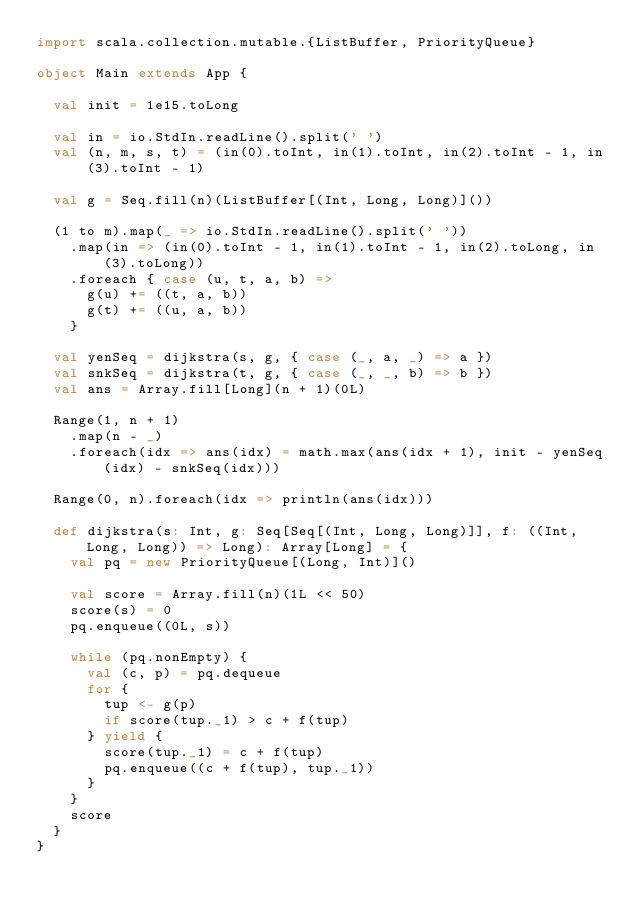<code> <loc_0><loc_0><loc_500><loc_500><_Scala_>import scala.collection.mutable.{ListBuffer, PriorityQueue}

object Main extends App {

  val init = 1e15.toLong

  val in = io.StdIn.readLine().split(' ')
  val (n, m, s, t) = (in(0).toInt, in(1).toInt, in(2).toInt - 1, in(3).toInt - 1)

  val g = Seq.fill(n)(ListBuffer[(Int, Long, Long)]())

  (1 to m).map(_ => io.StdIn.readLine().split(' '))
    .map(in => (in(0).toInt - 1, in(1).toInt - 1, in(2).toLong, in(3).toLong))
    .foreach { case (u, t, a, b) =>
      g(u) += ((t, a, b))
      g(t) += ((u, a, b))
    }

  val yenSeq = dijkstra(s, g, { case (_, a, _) => a })
  val snkSeq = dijkstra(t, g, { case (_, _, b) => b })
  val ans = Array.fill[Long](n + 1)(0L)

  Range(1, n + 1)
    .map(n - _)
    .foreach(idx => ans(idx) = math.max(ans(idx + 1), init - yenSeq(idx) - snkSeq(idx)))

  Range(0, n).foreach(idx => println(ans(idx)))

  def dijkstra(s: Int, g: Seq[Seq[(Int, Long, Long)]], f: ((Int, Long, Long)) => Long): Array[Long] = {
    val pq = new PriorityQueue[(Long, Int)]()

    val score = Array.fill(n)(1L << 50)
    score(s) = 0
    pq.enqueue((0L, s))

    while (pq.nonEmpty) {
      val (c, p) = pq.dequeue
      for {
        tup <- g(p)
        if score(tup._1) > c + f(tup)
      } yield {
        score(tup._1) = c + f(tup)
        pq.enqueue((c + f(tup), tup._1))
      }
    }
    score
  }
}
</code> 